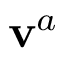<formula> <loc_0><loc_0><loc_500><loc_500>v ^ { a }</formula> 